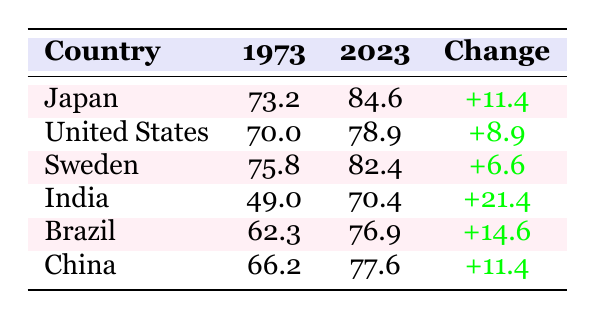What was the life expectancy in Japan in 1973? The table indicates that in 1973, the life expectancy in Japan was 73.2 years.
Answer: 73.2 What was the improvement in life expectancy for the United States from 1973 to 2023? By subtracting the life expectancy in 1973 (70.0) from that in 2023 (78.9), we find the improvement: 78.9 - 70.0 = 8.9 years.
Answer: 8.9 Is the life expectancy in Sweden higher in 2023 than in Japan in 1973? The life expectancy in Sweden in 2023 is 82.4 years, while in Japan in 1973 it was 73.2 years. Since 82.4 is greater than 73.2, the statement is true.
Answer: Yes What is the average life expectancy of Brazil in 1973 and 2023 combined? First, we find the values: in 1973 it was 62.3 and in 2023 it is 76.9. We sum these values: 62.3 + 76.9 = 139.2, then divide by 2 to find the average: 139.2 / 2 = 69.6.
Answer: 69.6 Which country had the highest life expectancy in 2023? Looking at the table, Japan has the highest life expectancy in 2023 at 84.6 years.
Answer: Japan What is the total increase in life expectancy for India from 1973 to 2023? The life expectancy in India increased from 49.0 in 1973 to 70.4 in 2023. The increase is calculated as 70.4 - 49.0 = 21.4 years.
Answer: 21.4 Is the life expectancy in China closer to the life expectancy of the United States in 2023 or Japan in 1973? In China, it's 77.6 in 2023, the U.S. is 78.9 in 2023, and Japan is 73.2 in 1973. 77.6 is closer to 78.9 than to 73.2, so it’s closer to the U.S.
Answer: Closer to the United States What was the difference in life expectancy between Brazil and India in 2023? Brazil's life expectancy in 2023 is 76.9, while India's is 70.4. The difference is 76.9 - 70.4 = 6.5 years.
Answer: 6.5 Which country showed the largest increase in life expectancy over the 50 years? India had the largest increase in life expectancy, with an increase of 21.4 years from 49.0 in 1973 to 70.4 in 2023.
Answer: India 